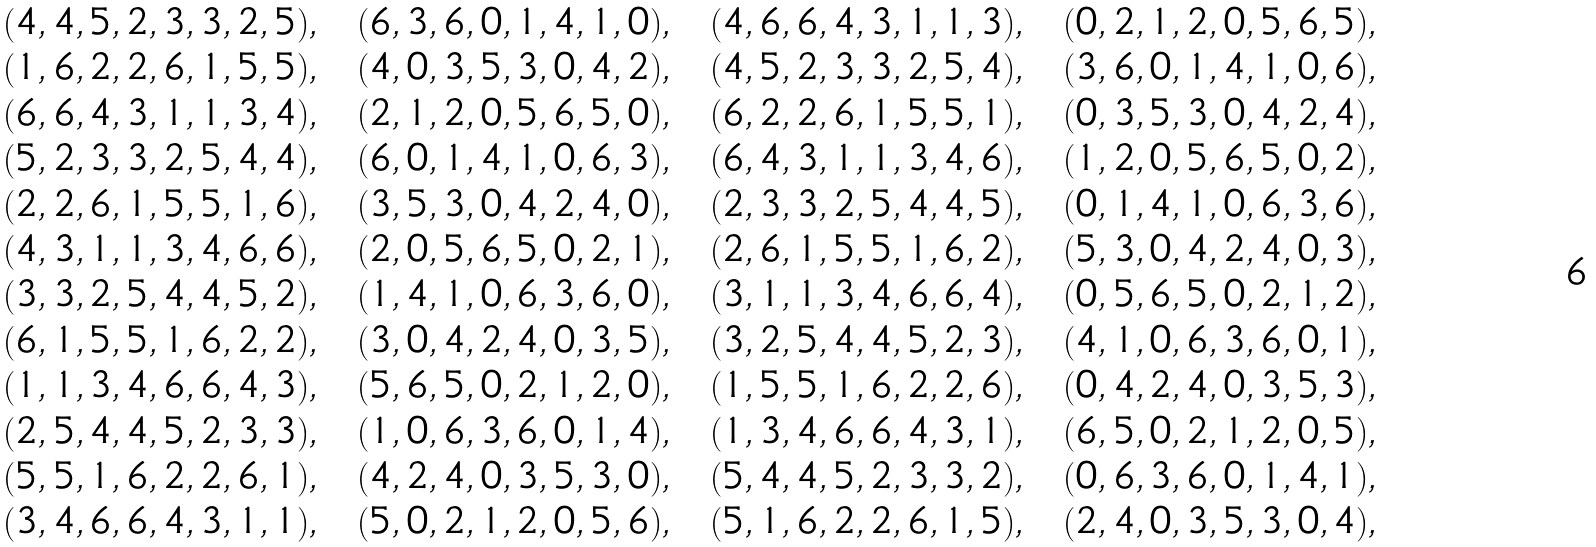<formula> <loc_0><loc_0><loc_500><loc_500>& ( 4 , 4 , 5 , 2 , 3 , 3 , 2 , 5 ) , \ \ ( 6 , 3 , 6 , 0 , 1 , 4 , 1 , 0 ) , \ \ ( 4 , 6 , 6 , 4 , 3 , 1 , 1 , 3 ) , \ \ ( 0 , 2 , 1 , 2 , 0 , 5 , 6 , 5 ) , \\ & ( 1 , 6 , 2 , 2 , 6 , 1 , 5 , 5 ) , \ \ ( 4 , 0 , 3 , 5 , 3 , 0 , 4 , 2 ) , \ \ ( 4 , 5 , 2 , 3 , 3 , 2 , 5 , 4 ) , \ \ ( 3 , 6 , 0 , 1 , 4 , 1 , 0 , 6 ) , \\ & ( 6 , 6 , 4 , 3 , 1 , 1 , 3 , 4 ) , \ \ ( 2 , 1 , 2 , 0 , 5 , 6 , 5 , 0 ) , \ \ ( 6 , 2 , 2 , 6 , 1 , 5 , 5 , 1 ) , \ \ ( 0 , 3 , 5 , 3 , 0 , 4 , 2 , 4 ) , \\ & ( 5 , 2 , 3 , 3 , 2 , 5 , 4 , 4 ) , \ \ ( 6 , 0 , 1 , 4 , 1 , 0 , 6 , 3 ) , \ \ ( 6 , 4 , 3 , 1 , 1 , 3 , 4 , 6 ) , \ \ ( 1 , 2 , 0 , 5 , 6 , 5 , 0 , 2 ) , \\ & ( 2 , 2 , 6 , 1 , 5 , 5 , 1 , 6 ) , \ \ ( 3 , 5 , 3 , 0 , 4 , 2 , 4 , 0 ) , \ \ ( 2 , 3 , 3 , 2 , 5 , 4 , 4 , 5 ) , \ \ ( 0 , 1 , 4 , 1 , 0 , 6 , 3 , 6 ) , \\ & ( 4 , 3 , 1 , 1 , 3 , 4 , 6 , 6 ) , \ \ ( 2 , 0 , 5 , 6 , 5 , 0 , 2 , 1 ) , \ \ ( 2 , 6 , 1 , 5 , 5 , 1 , 6 , 2 ) , \ \ ( 5 , 3 , 0 , 4 , 2 , 4 , 0 , 3 ) , \\ & ( 3 , 3 , 2 , 5 , 4 , 4 , 5 , 2 ) , \ \ ( 1 , 4 , 1 , 0 , 6 , 3 , 6 , 0 ) , \ \ ( 3 , 1 , 1 , 3 , 4 , 6 , 6 , 4 ) , \ \ ( 0 , 5 , 6 , 5 , 0 , 2 , 1 , 2 ) , \\ & ( 6 , 1 , 5 , 5 , 1 , 6 , 2 , 2 ) , \ \ ( 3 , 0 , 4 , 2 , 4 , 0 , 3 , 5 ) , \ \ ( 3 , 2 , 5 , 4 , 4 , 5 , 2 , 3 ) , \ \ ( 4 , 1 , 0 , 6 , 3 , 6 , 0 , 1 ) , \\ & ( 1 , 1 , 3 , 4 , 6 , 6 , 4 , 3 ) , \ \ ( 5 , 6 , 5 , 0 , 2 , 1 , 2 , 0 ) , \ \ ( 1 , 5 , 5 , 1 , 6 , 2 , 2 , 6 ) , \ \ ( 0 , 4 , 2 , 4 , 0 , 3 , 5 , 3 ) , \\ & ( 2 , 5 , 4 , 4 , 5 , 2 , 3 , 3 ) , \ \ ( 1 , 0 , 6 , 3 , 6 , 0 , 1 , 4 ) , \ \ ( 1 , 3 , 4 , 6 , 6 , 4 , 3 , 1 ) , \ \ ( 6 , 5 , 0 , 2 , 1 , 2 , 0 , 5 ) , \\ & ( 5 , 5 , 1 , 6 , 2 , 2 , 6 , 1 ) , \ \ ( 4 , 2 , 4 , 0 , 3 , 5 , 3 , 0 ) , \ \ ( 5 , 4 , 4 , 5 , 2 , 3 , 3 , 2 ) , \ \ ( 0 , 6 , 3 , 6 , 0 , 1 , 4 , 1 ) , \\ & ( 3 , 4 , 6 , 6 , 4 , 3 , 1 , 1 ) , \ \ ( 5 , 0 , 2 , 1 , 2 , 0 , 5 , 6 ) , \ \ ( 5 , 1 , 6 , 2 , 2 , 6 , 1 , 5 ) , \ \ ( 2 , 4 , 0 , 3 , 5 , 3 , 0 , 4 ) , \\</formula> 